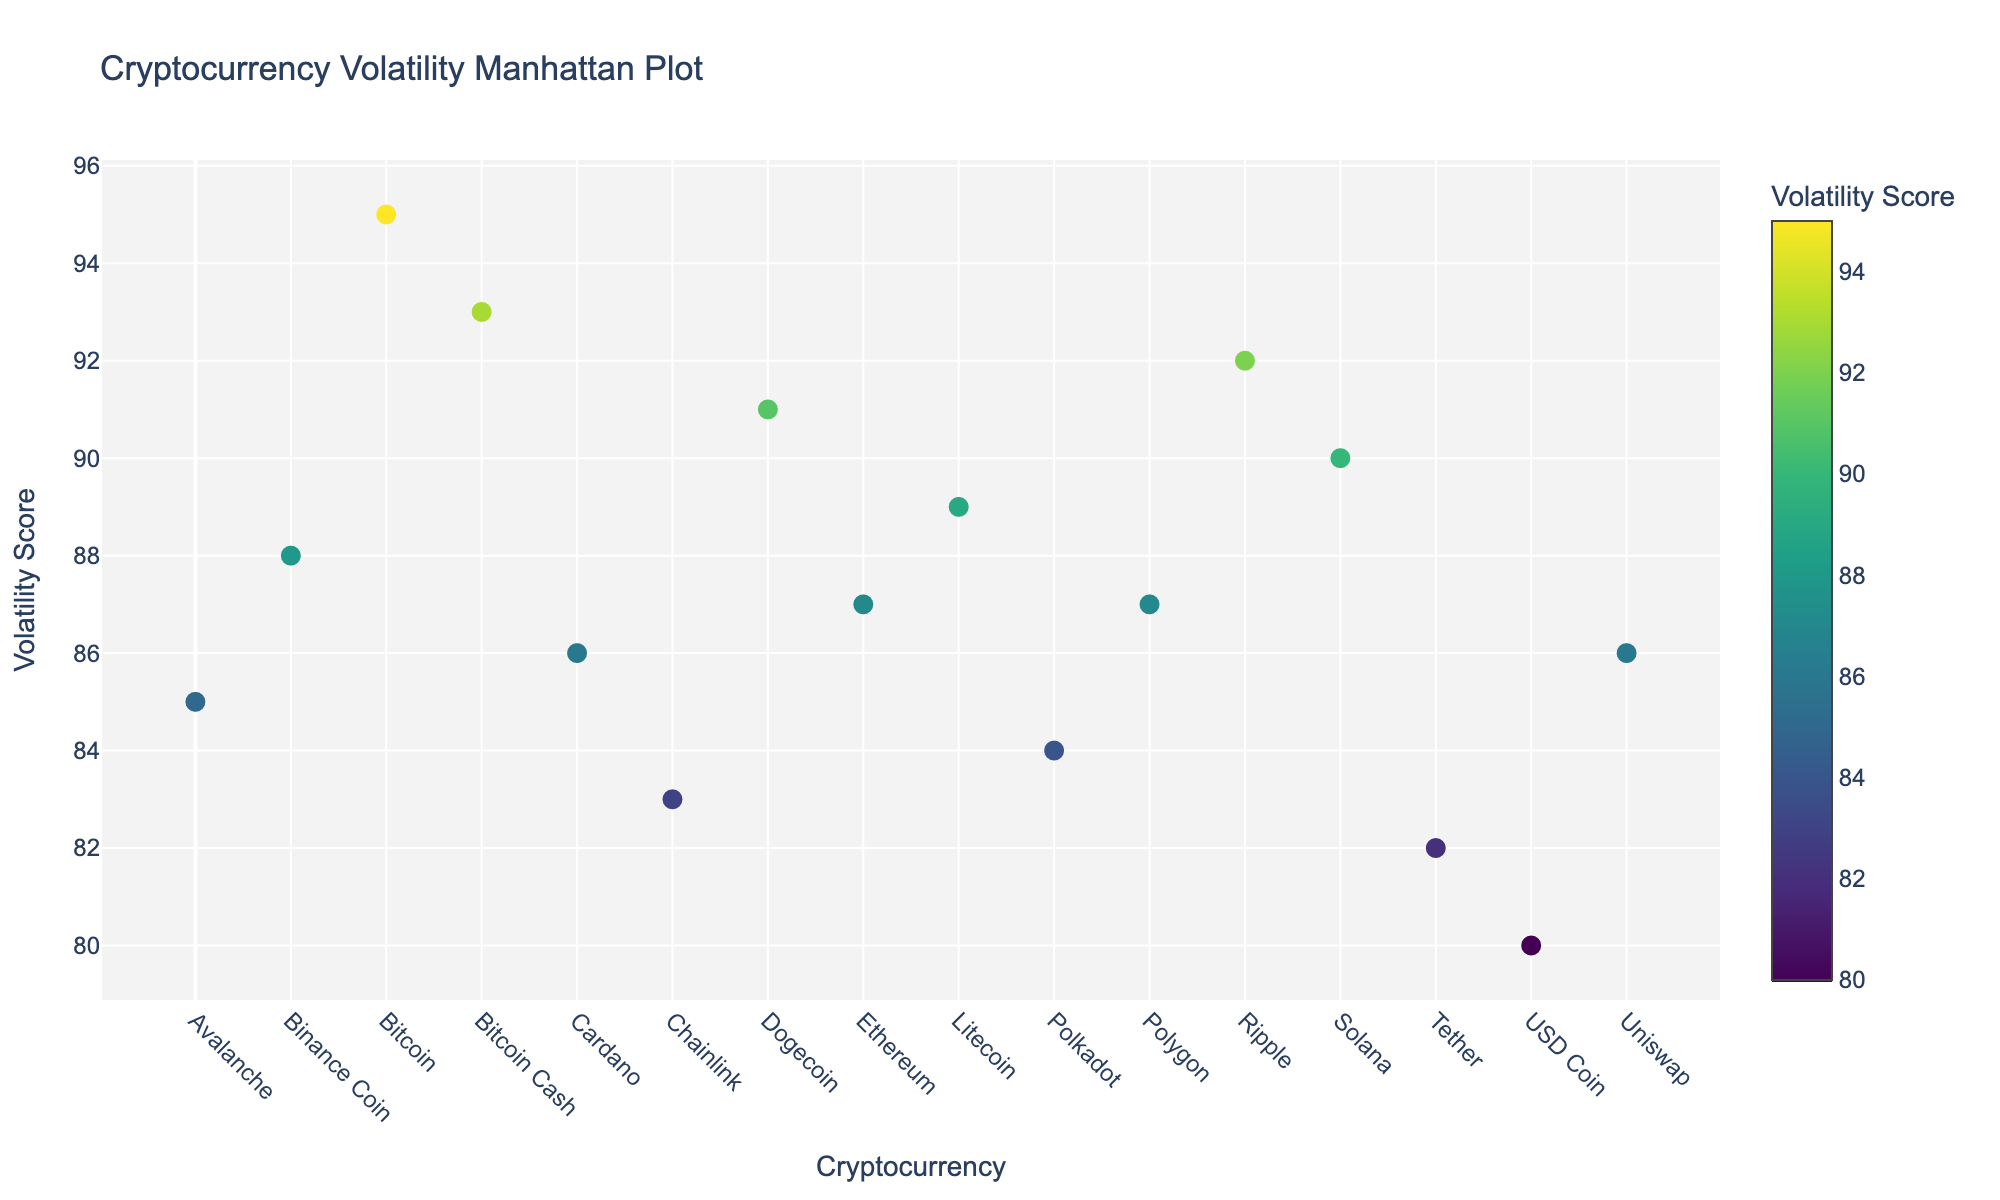What is the title of the plot? The title of the plot is usually displayed at the top of the figure, which helps identify the subject of the data visualization.
Answer: Cryptocurrency Volatility Manhattan Plot Which cryptocurrency had the highest volatility score? To find out the cryptocurrency with the highest volatility score, look for the highest point on the y-axis and read the corresponding x-axis label.
Answer: Bitcoin How many cryptocurrencies had a volatility score higher than 90? Identify the data points above the y-axis value of 90 and count the number of these points.
Answer: 6 What event is associated with the highest volatility score? Locate the highest data point on the plot and check the event associated with this point from the hover information or the plot's text annotations.
Answer: All-time high Which two cryptocurrencies have the closest volatility scores, and what are those scores? Identify data points that are close together on the y-axis and compare them.
Answer: UST collapse impact associated with Tether scored 82 and DeFi summer peak associated with Chainlink scored 83, which are the closest Which cryptocurrency shows a spike due to the Silicon Valley Bank closure, and what is its volatility score? Look for the text "Silicon Valley Bank closure," and find the corresponding y-axis value.
Answer: USD Coin, 80 What is the average volatility score of all cryptocurrencies listed? Sum all the volatility scores and divide by the total number of cryptocurrencies. Sum = 95+87+92+89+93+86+91+88+84+90+85+82+80+83+86+87. Average = Sum / 16 = 1348 / 16
Answer: 84.25 Which cryptocurrency had a major event related to the network outage and what was its volatility score? Find the event labeled "Network outage" and determine the corresponding cryptocurrency and its y-axis value.
Answer: Solana, 90 What cryptocurrency had increased volatility due to the Coinbase listing speculation, and was there another cryptocurrency with a higher score at that time? Identify the event "Coinbase listing speculation," find the corresponding cryptocurrency, and verify if any other cryptocurrency had a higher score around the same time (e.g., January 4, 2018).
Answer: Ripple, and yes, Bitcoin had a higher score 